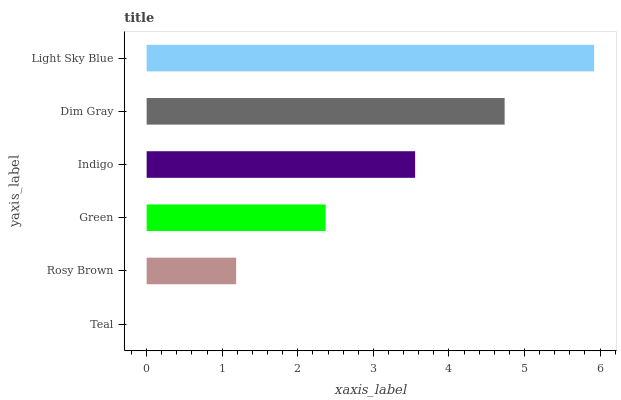Is Teal the minimum?
Answer yes or no. Yes. Is Light Sky Blue the maximum?
Answer yes or no. Yes. Is Rosy Brown the minimum?
Answer yes or no. No. Is Rosy Brown the maximum?
Answer yes or no. No. Is Rosy Brown greater than Teal?
Answer yes or no. Yes. Is Teal less than Rosy Brown?
Answer yes or no. Yes. Is Teal greater than Rosy Brown?
Answer yes or no. No. Is Rosy Brown less than Teal?
Answer yes or no. No. Is Indigo the high median?
Answer yes or no. Yes. Is Green the low median?
Answer yes or no. Yes. Is Rosy Brown the high median?
Answer yes or no. No. Is Teal the low median?
Answer yes or no. No. 